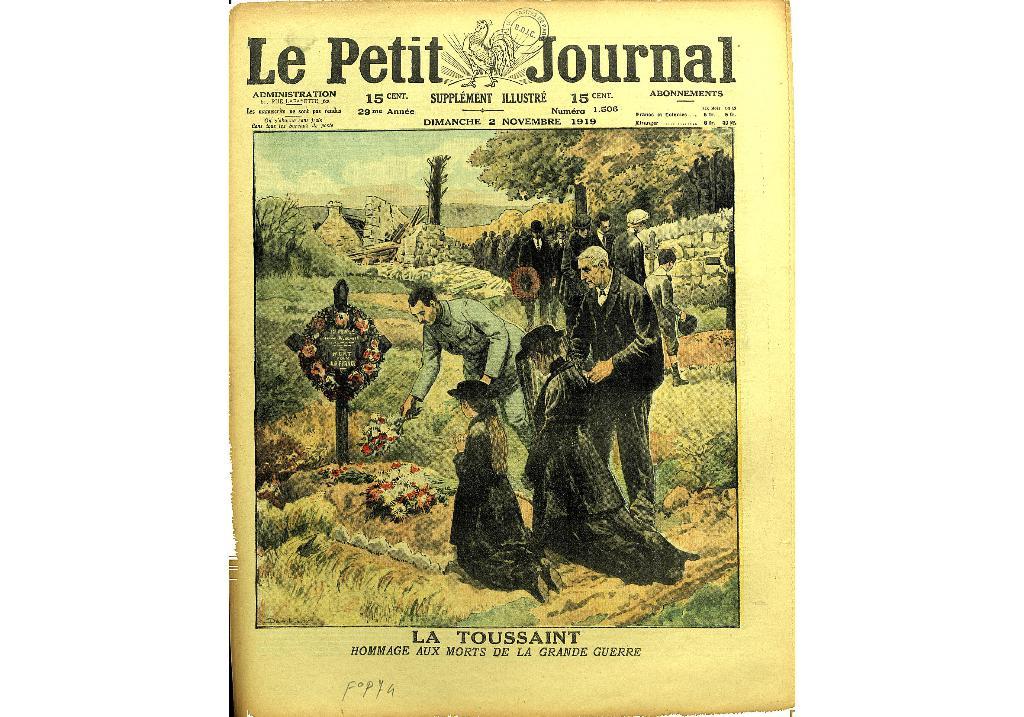What journal is this?
Provide a succinct answer. Le petit. 